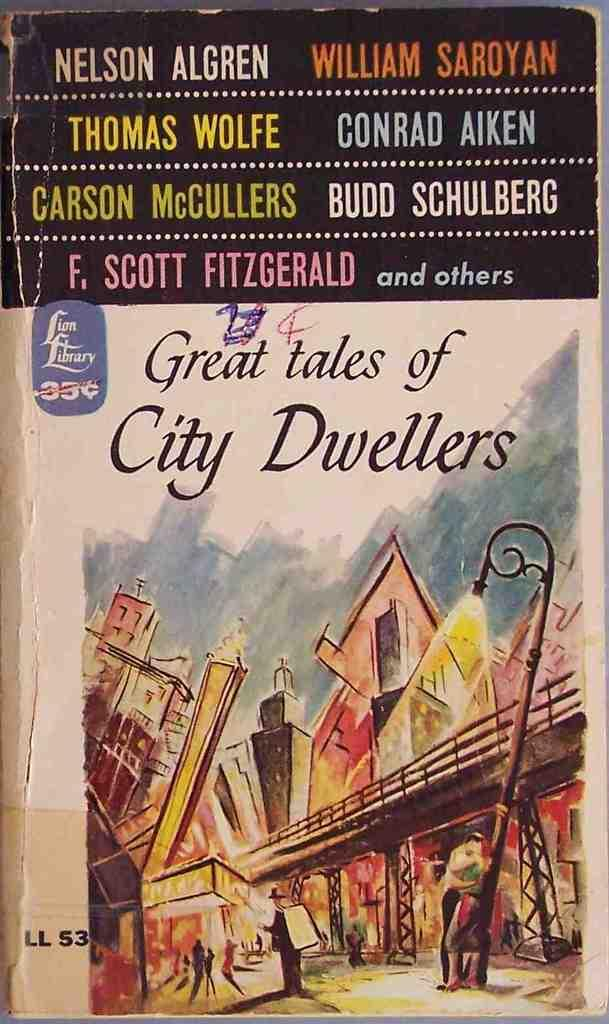<image>
Render a clear and concise summary of the photo. The cover of a paperback book titled Great tales of City Dwellers. 